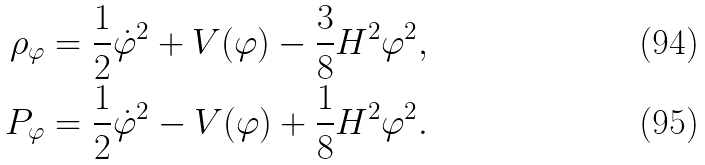<formula> <loc_0><loc_0><loc_500><loc_500>\rho _ { \varphi } & = \frac { 1 } { 2 } \dot { \varphi } ^ { 2 } + V ( \varphi ) - \frac { 3 } { 8 } H ^ { 2 } \varphi ^ { 2 } , \\ P _ { \varphi } & = \frac { 1 } { 2 } \dot { \varphi } ^ { 2 } - V ( \varphi ) + \frac { 1 } { 8 } H ^ { 2 } \varphi ^ { 2 } .</formula> 